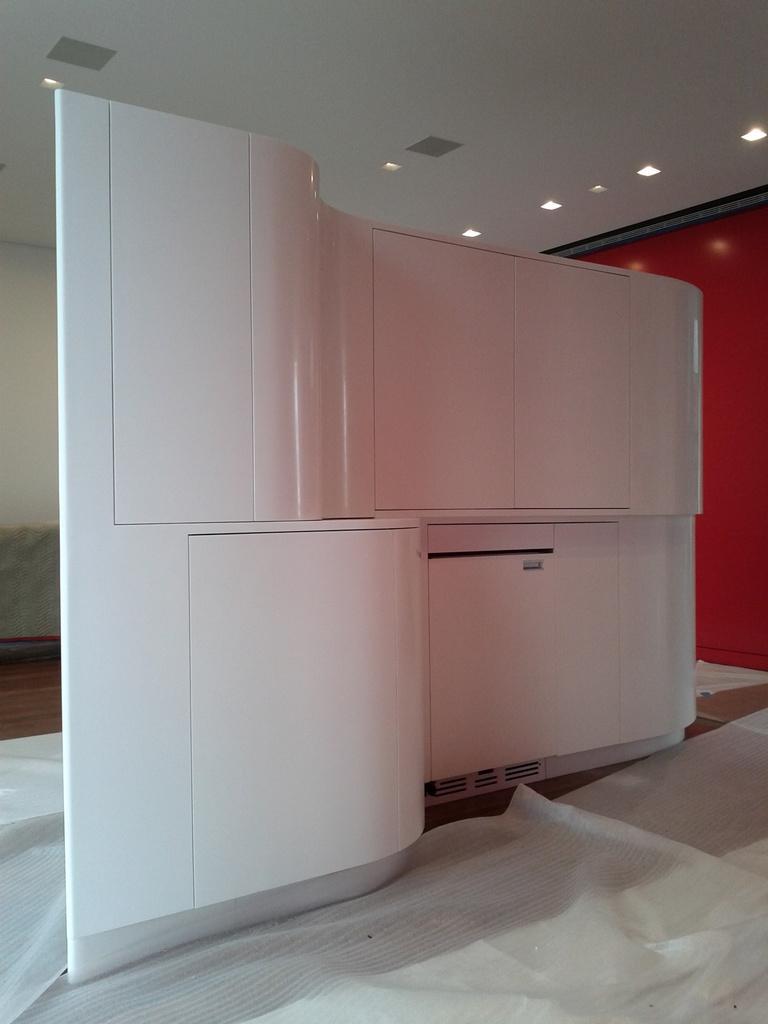How would you summarize this image in a sentence or two? In this picture we can see furniture and white sheets on the floor. In the background of the image we can see wall. At the top of the image we can see the lights. 